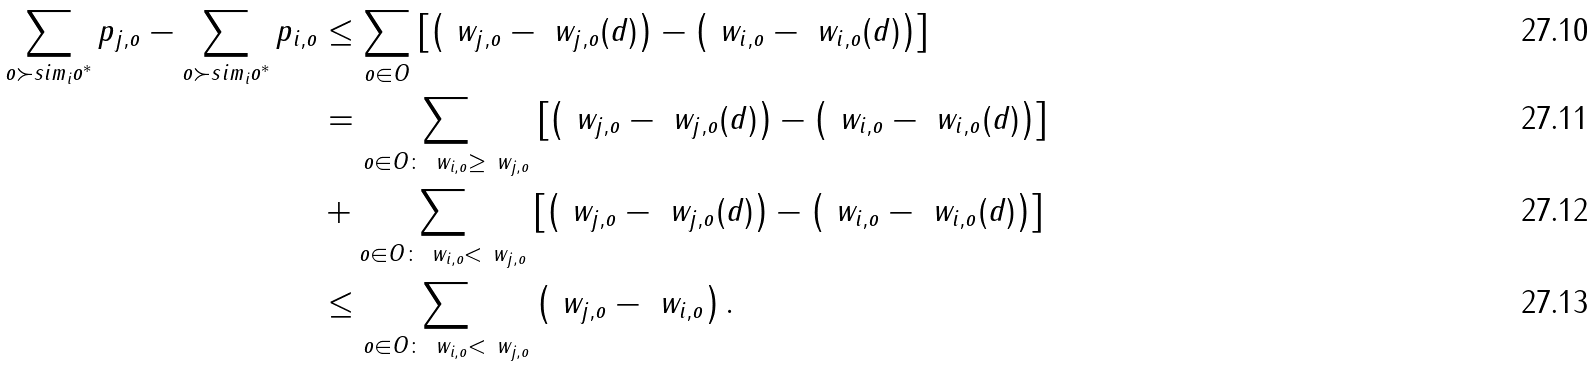Convert formula to latex. <formula><loc_0><loc_0><loc_500><loc_500>\sum _ { o \succ s i m _ { i } o ^ { * } } p _ { j , o } - \sum _ { o \succ s i m _ { i } o ^ { * } } p _ { i , o } & \leq \sum _ { o \in O } \left [ \left ( \ w _ { j , o } - \ w _ { j , o } ( d ) \right ) - \left ( \ w _ { i , o } - \ w _ { i , o } ( d ) \right ) \right ] \\ & = \sum _ { o \in O \colon \ w _ { i , o } \geq \ w _ { j , o } } \left [ \left ( \ w _ { j , o } - \ w _ { j , o } ( d ) \right ) - \left ( \ w _ { i , o } - \ w _ { i , o } ( d ) \right ) \right ] \\ & + \sum _ { o \in O \colon \ w _ { i , o } < \ w _ { j , o } } \left [ \left ( \ w _ { j , o } - \ w _ { j , o } ( d ) \right ) - \left ( \ w _ { i , o } - \ w _ { i , o } ( d ) \right ) \right ] \\ & \leq \sum _ { o \in O \colon \ w _ { i , o } < \ w _ { j , o } } \left ( \ w _ { j , o } - \ w _ { i , o } \right ) .</formula> 